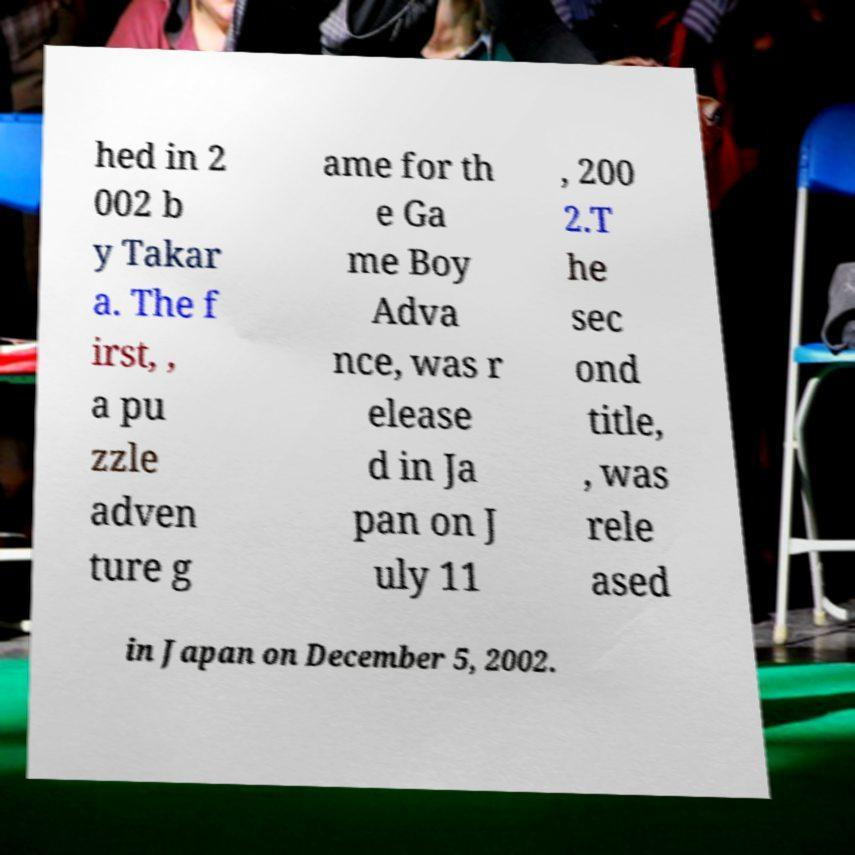Please identify and transcribe the text found in this image. hed in 2 002 b y Takar a. The f irst, , a pu zzle adven ture g ame for th e Ga me Boy Adva nce, was r elease d in Ja pan on J uly 11 , 200 2.T he sec ond title, , was rele ased in Japan on December 5, 2002. 